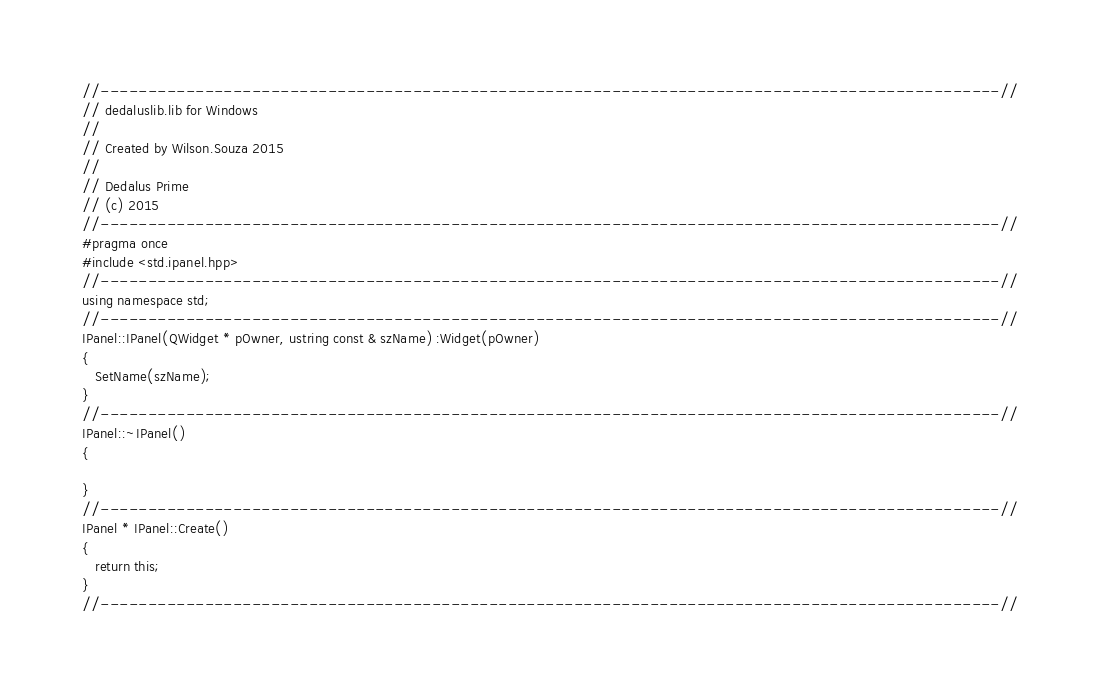Convert code to text. <code><loc_0><loc_0><loc_500><loc_500><_C++_>//-----------------------------------------------------------------------------------------------//
// dedaluslib.lib for Windows
//
// Created by Wilson.Souza 2015
//
// Dedalus Prime
// (c) 2015
//-----------------------------------------------------------------------------------------------//
#pragma once
#include <std.ipanel.hpp>
//-----------------------------------------------------------------------------------------------//
using namespace std;
//-----------------------------------------------------------------------------------------------//
IPanel::IPanel(QWidget * pOwner, ustring const & szName) :Widget(pOwner)
{
   SetName(szName);
}
//-----------------------------------------------------------------------------------------------//
IPanel::~IPanel()
{

}
//-----------------------------------------------------------------------------------------------//
IPanel * IPanel::Create()
{
   return this;
}
//-----------------------------------------------------------------------------------------------//
</code> 